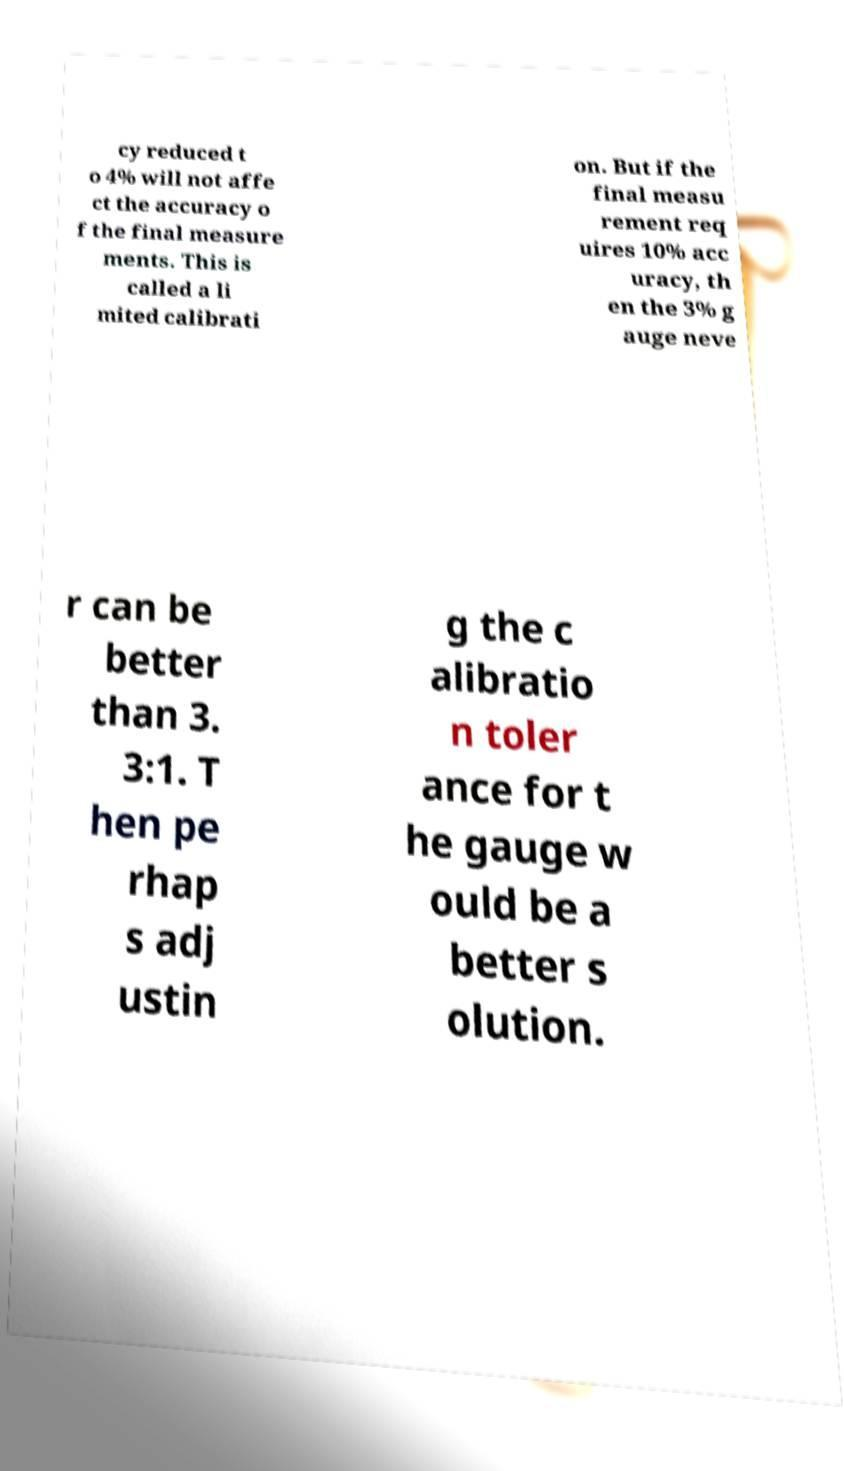Could you extract and type out the text from this image? cy reduced t o 4% will not affe ct the accuracy o f the final measure ments. This is called a li mited calibrati on. But if the final measu rement req uires 10% acc uracy, th en the 3% g auge neve r can be better than 3. 3:1. T hen pe rhap s adj ustin g the c alibratio n toler ance for t he gauge w ould be a better s olution. 